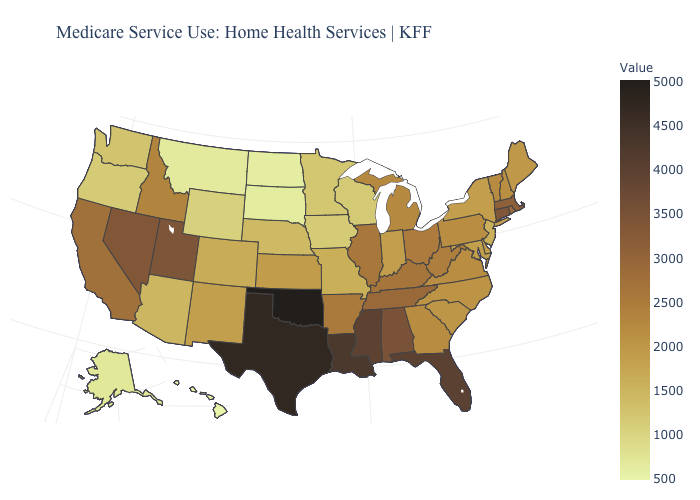Which states have the lowest value in the USA?
Short answer required. Hawaii. Does Oklahoma have the highest value in the USA?
Answer briefly. Yes. Does Illinois have the lowest value in the MidWest?
Keep it brief. No. Does West Virginia have a higher value than Texas?
Give a very brief answer. No. Does Massachusetts have a lower value than Texas?
Keep it brief. Yes. 